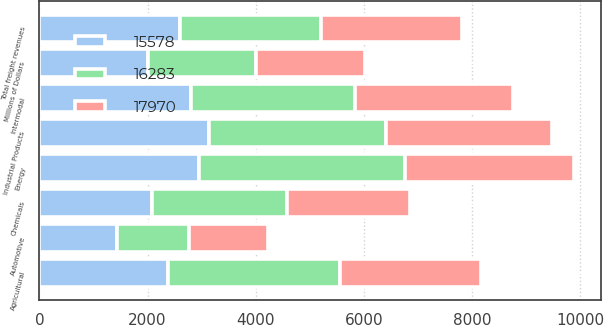Convert chart. <chart><loc_0><loc_0><loc_500><loc_500><stacked_bar_chart><ecel><fcel>Millions of Dollars<fcel>Agricultural<fcel>Automotive<fcel>Chemicals<fcel>Energy<fcel>Industrial Products<fcel>Intermodal<fcel>Total freight revenues<nl><fcel>16283<fcel>2008<fcel>3174<fcel>1344<fcel>2494<fcel>3810<fcel>3273<fcel>3023<fcel>2605<nl><fcel>17970<fcel>2007<fcel>2605<fcel>1458<fcel>2287<fcel>3134<fcel>3077<fcel>2925<fcel>2605<nl><fcel>15578<fcel>2006<fcel>2385<fcel>1427<fcel>2084<fcel>2949<fcel>3135<fcel>2811<fcel>2605<nl></chart> 